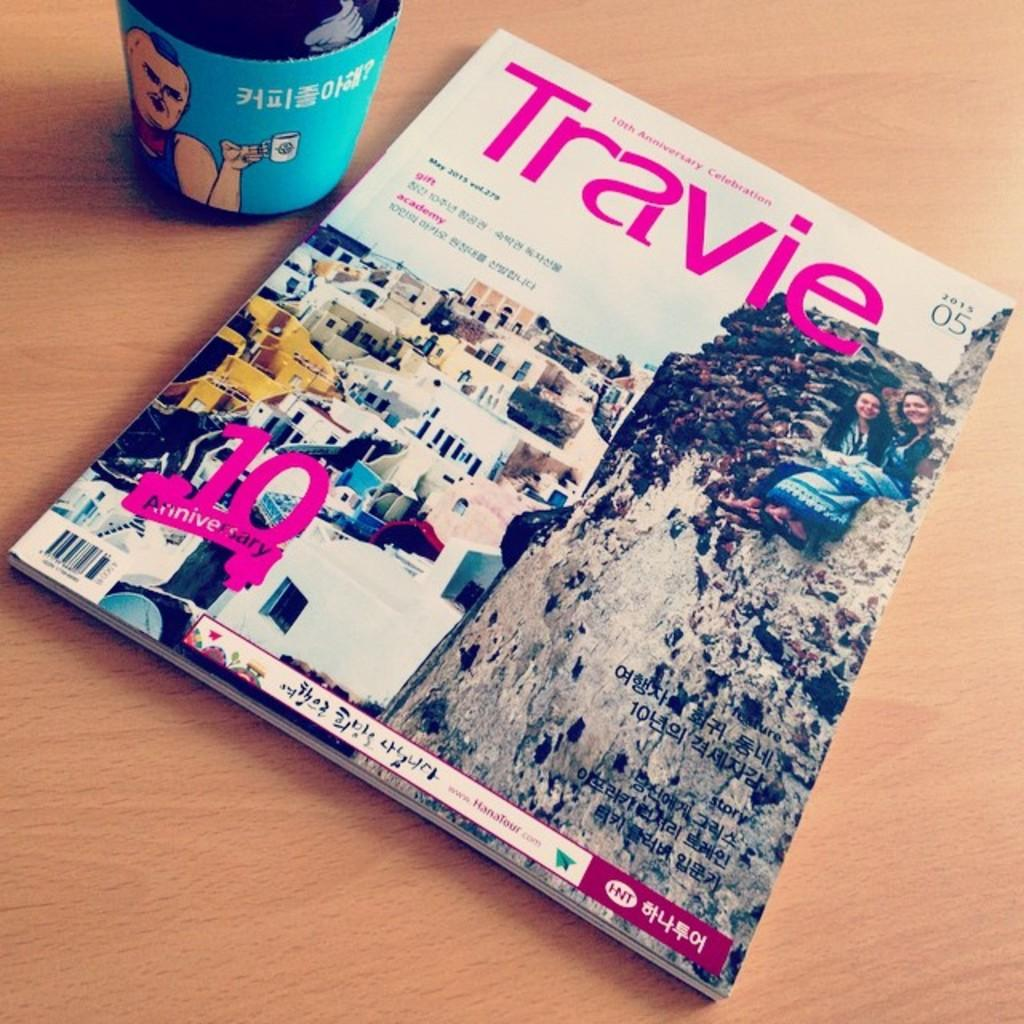<image>
Create a compact narrative representing the image presented. A 10 Anniversary magazine called Travie from 2015. 